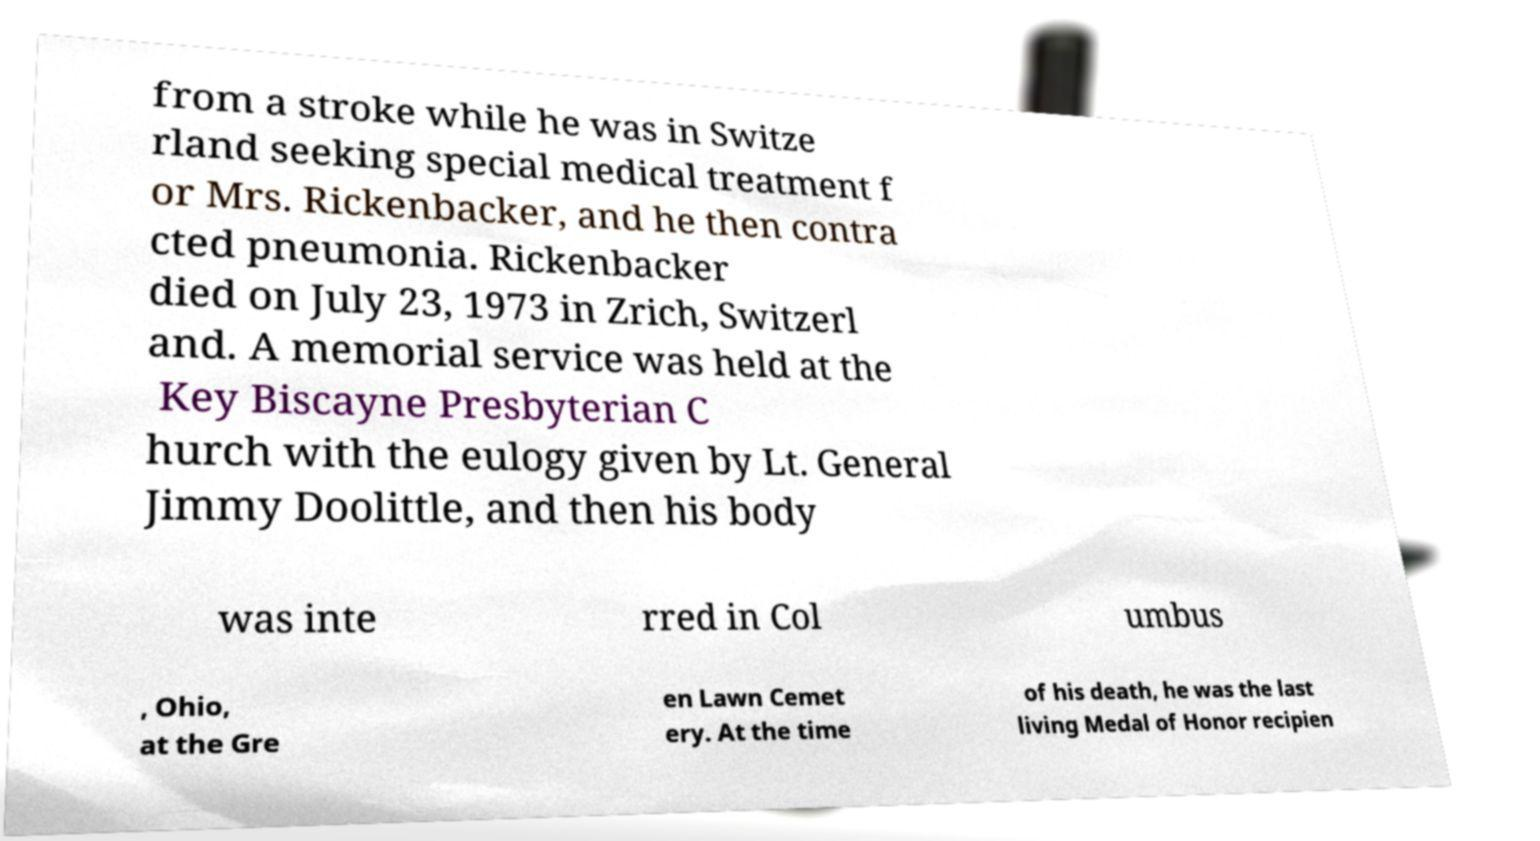Can you accurately transcribe the text from the provided image for me? from a stroke while he was in Switze rland seeking special medical treatment f or Mrs. Rickenbacker, and he then contra cted pneumonia. Rickenbacker died on July 23, 1973 in Zrich, Switzerl and. A memorial service was held at the Key Biscayne Presbyterian C hurch with the eulogy given by Lt. General Jimmy Doolittle, and then his body was inte rred in Col umbus , Ohio, at the Gre en Lawn Cemet ery. At the time of his death, he was the last living Medal of Honor recipien 